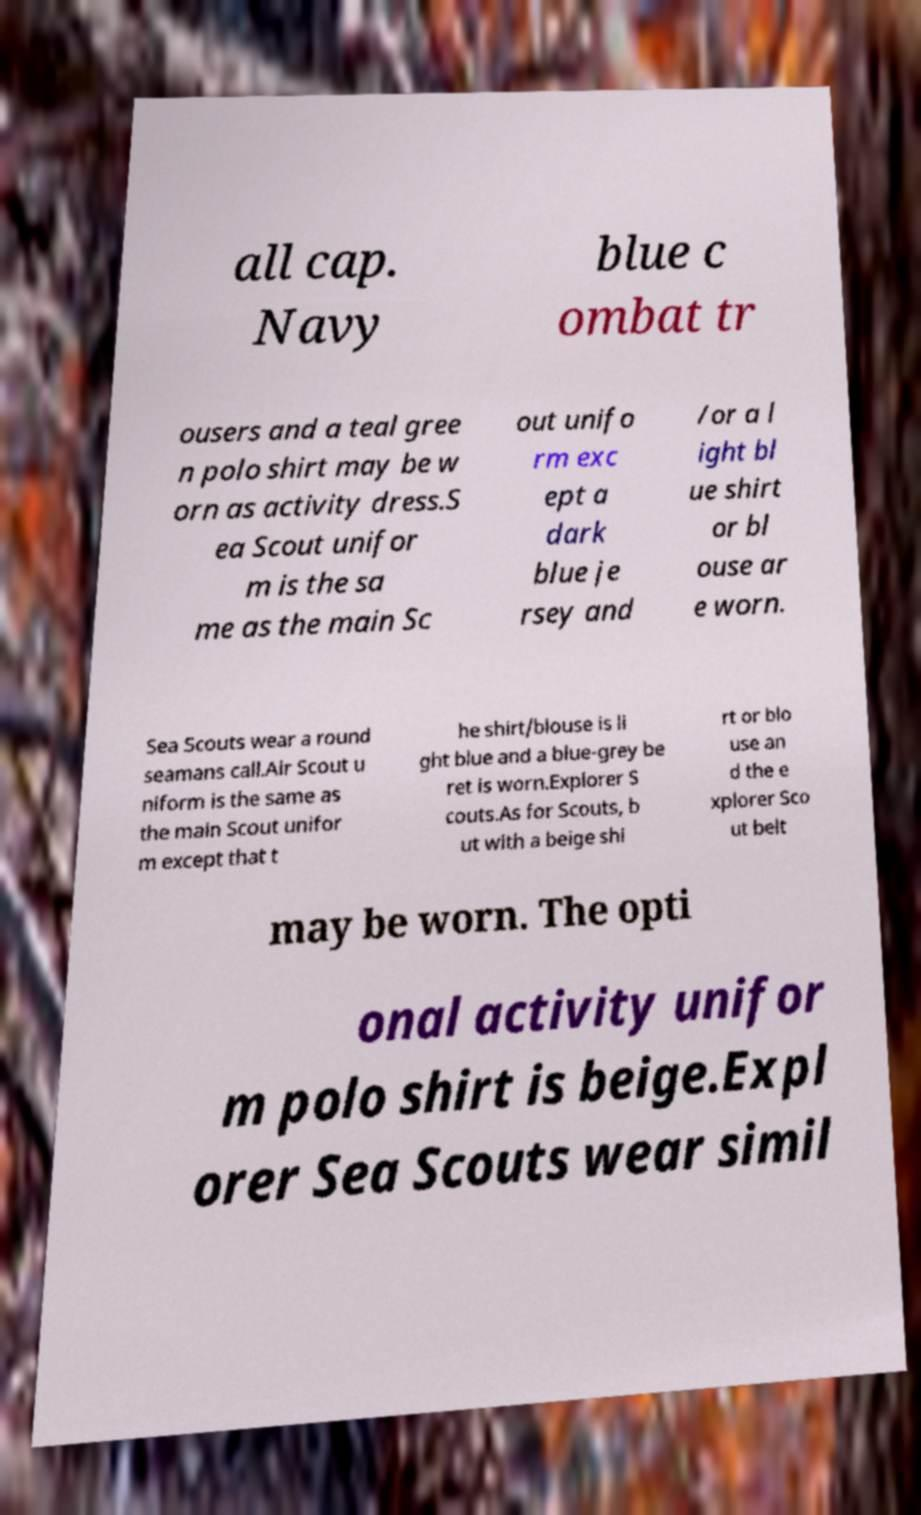Could you extract and type out the text from this image? all cap. Navy blue c ombat tr ousers and a teal gree n polo shirt may be w orn as activity dress.S ea Scout unifor m is the sa me as the main Sc out unifo rm exc ept a dark blue je rsey and /or a l ight bl ue shirt or bl ouse ar e worn. Sea Scouts wear a round seamans call.Air Scout u niform is the same as the main Scout unifor m except that t he shirt/blouse is li ght blue and a blue-grey be ret is worn.Explorer S couts.As for Scouts, b ut with a beige shi rt or blo use an d the e xplorer Sco ut belt may be worn. The opti onal activity unifor m polo shirt is beige.Expl orer Sea Scouts wear simil 